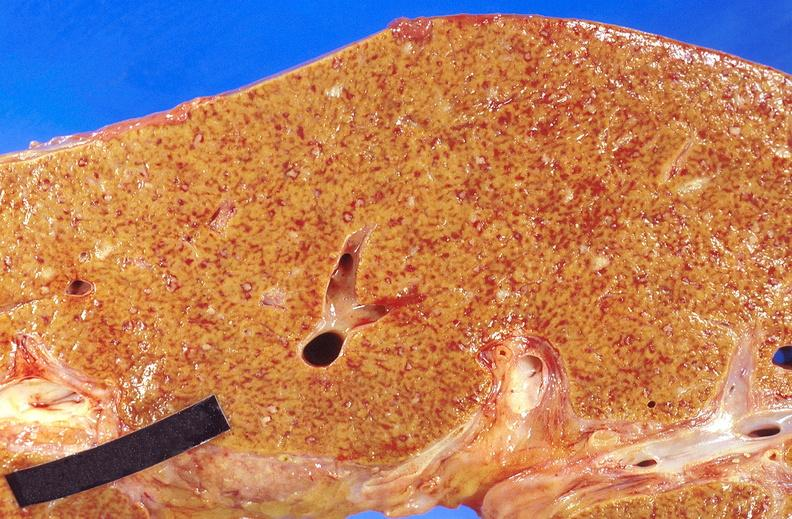s hepatobiliary present?
Answer the question using a single word or phrase. Yes 